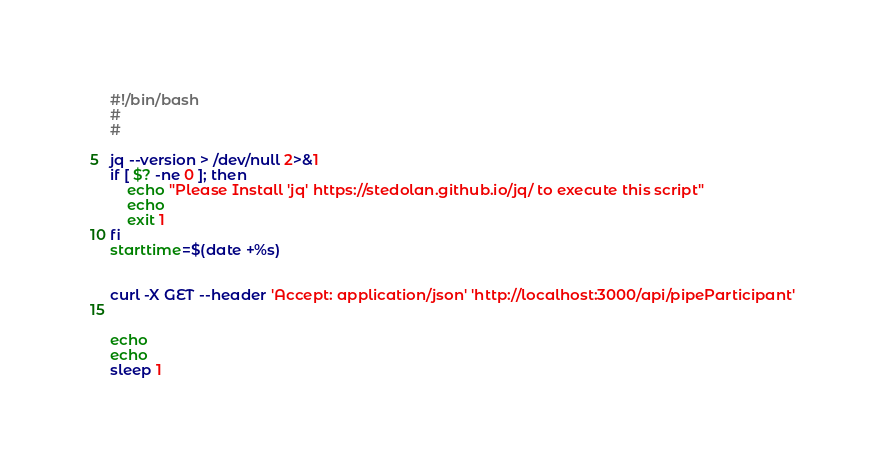<code> <loc_0><loc_0><loc_500><loc_500><_Bash_>#!/bin/bash
#
#

jq --version > /dev/null 2>&1
if [ $? -ne 0 ]; then
	echo "Please Install 'jq' https://stedolan.github.io/jq/ to execute this script"
	echo
	exit 1
fi
starttime=$(date +%s)


curl -X GET --header 'Accept: application/json' 'http://localhost:3000/api/pipeParticipant'


echo
echo
sleep 1</code> 